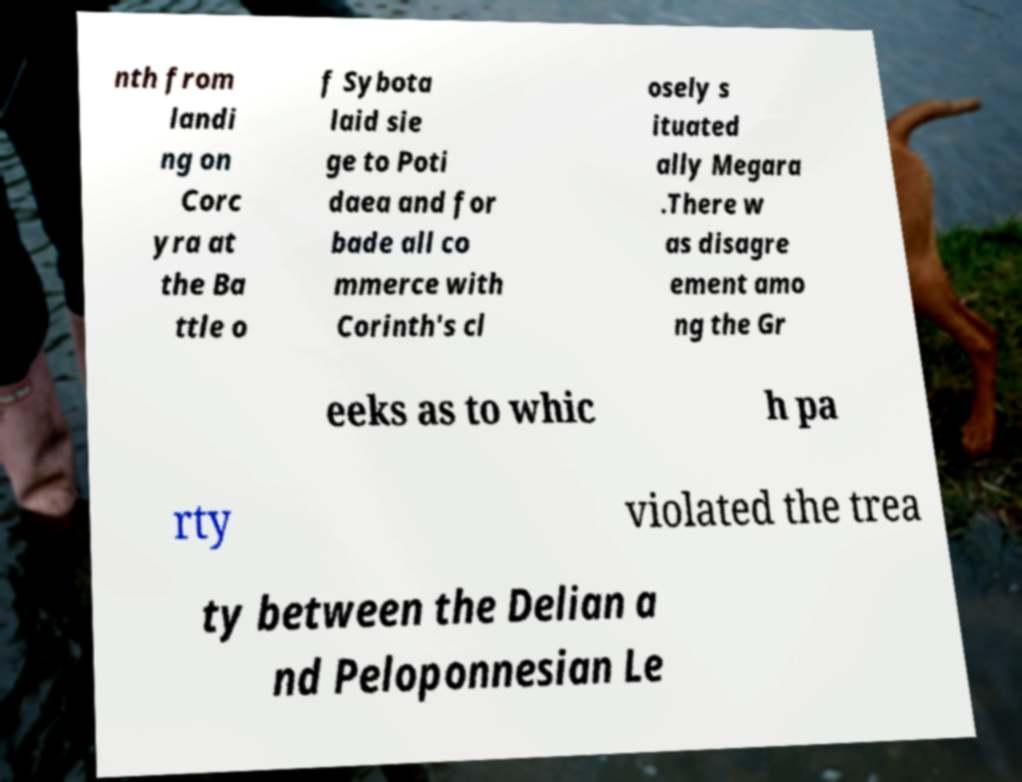Can you read and provide the text displayed in the image?This photo seems to have some interesting text. Can you extract and type it out for me? nth from landi ng on Corc yra at the Ba ttle o f Sybota laid sie ge to Poti daea and for bade all co mmerce with Corinth's cl osely s ituated ally Megara .There w as disagre ement amo ng the Gr eeks as to whic h pa rty violated the trea ty between the Delian a nd Peloponnesian Le 